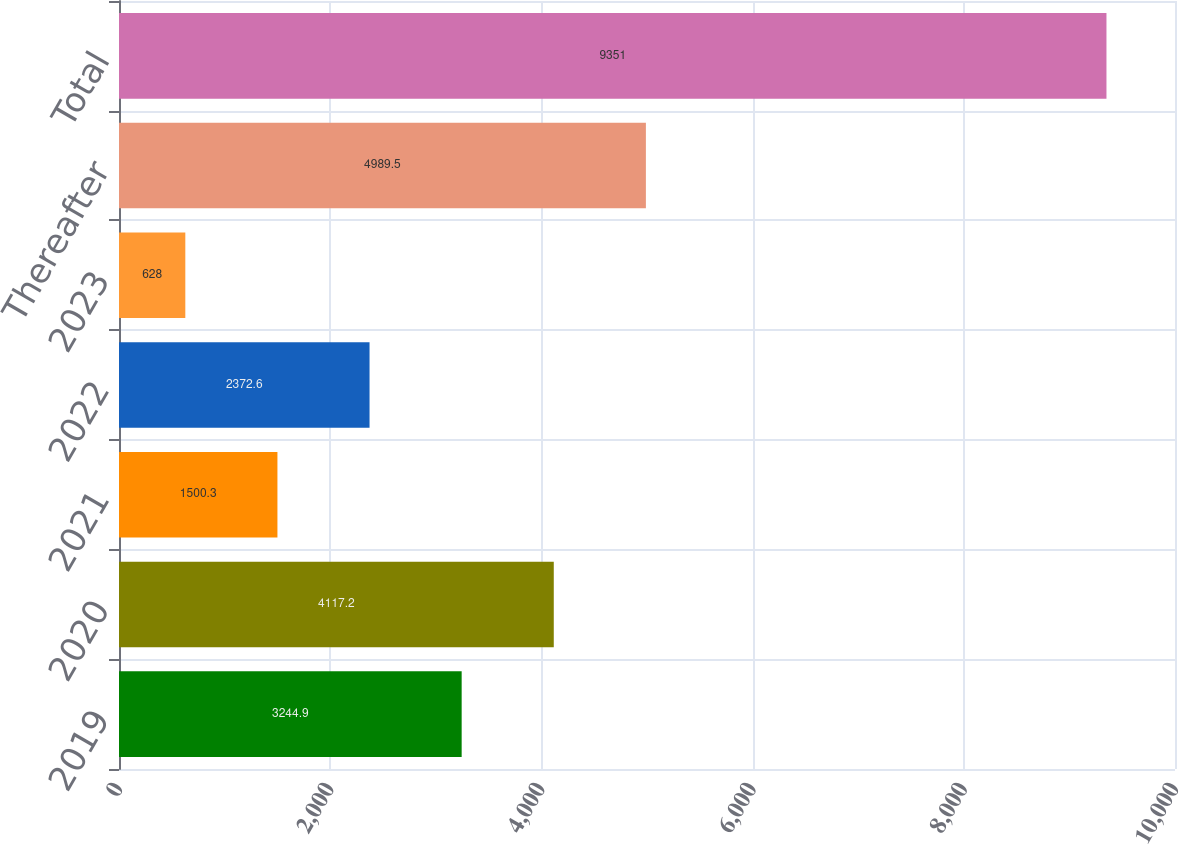<chart> <loc_0><loc_0><loc_500><loc_500><bar_chart><fcel>2019<fcel>2020<fcel>2021<fcel>2022<fcel>2023<fcel>Thereafter<fcel>Total<nl><fcel>3244.9<fcel>4117.2<fcel>1500.3<fcel>2372.6<fcel>628<fcel>4989.5<fcel>9351<nl></chart> 